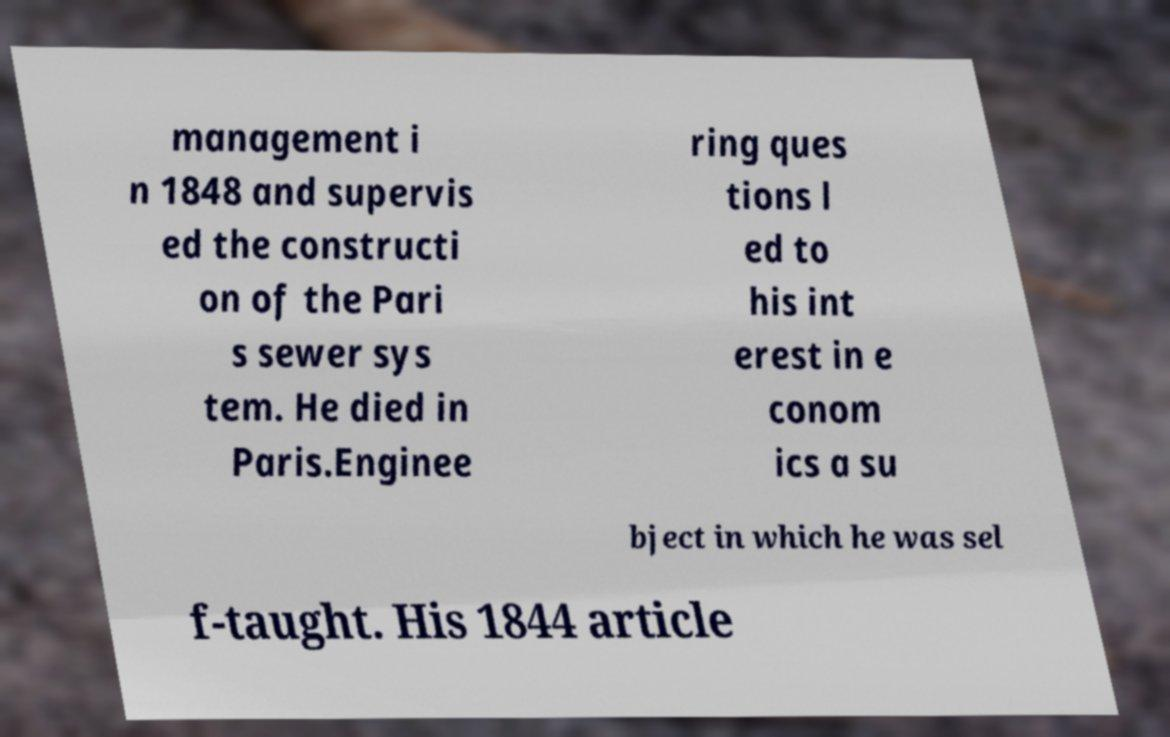Can you accurately transcribe the text from the provided image for me? management i n 1848 and supervis ed the constructi on of the Pari s sewer sys tem. He died in Paris.Enginee ring ques tions l ed to his int erest in e conom ics a su bject in which he was sel f-taught. His 1844 article 